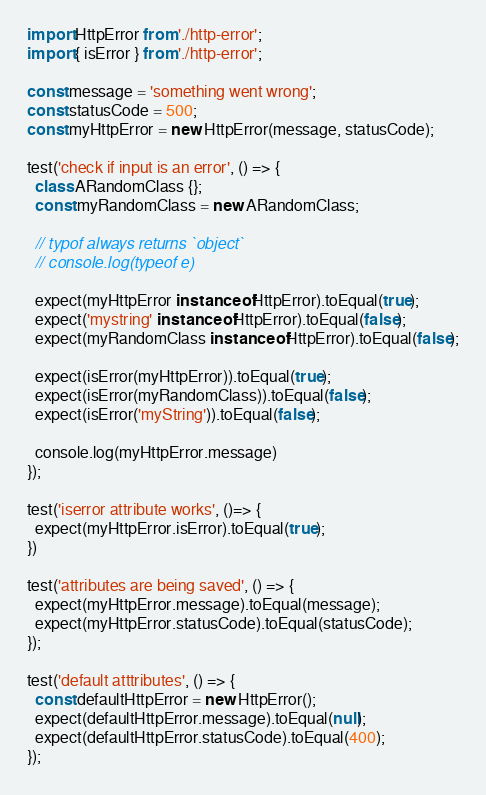Convert code to text. <code><loc_0><loc_0><loc_500><loc_500><_JavaScript_>import HttpError from './http-error';
import { isError } from './http-error';

const message = 'something went wrong';
const statusCode = 500;
const myHttpError = new HttpError(message, statusCode);

test('check if input is an error', () => {
  class ARandomClass {};
  const myRandomClass = new ARandomClass;

  // typof always returns `object`
  // console.log(typeof e)

  expect(myHttpError instanceof HttpError).toEqual(true);
  expect('mystring' instanceof HttpError).toEqual(false);
  expect(myRandomClass instanceof HttpError).toEqual(false);

  expect(isError(myHttpError)).toEqual(true);
  expect(isError(myRandomClass)).toEqual(false);
  expect(isError('myString')).toEqual(false);

  console.log(myHttpError.message)
});

test('iserror attribute works', ()=> {
  expect(myHttpError.isError).toEqual(true);
})

test('attributes are being saved', () => {
  expect(myHttpError.message).toEqual(message);
  expect(myHttpError.statusCode).toEqual(statusCode);
});

test('default atttributes', () => {
  const defaultHttpError = new HttpError();
  expect(defaultHttpError.message).toEqual(null);
  expect(defaultHttpError.statusCode).toEqual(400);
});


</code> 